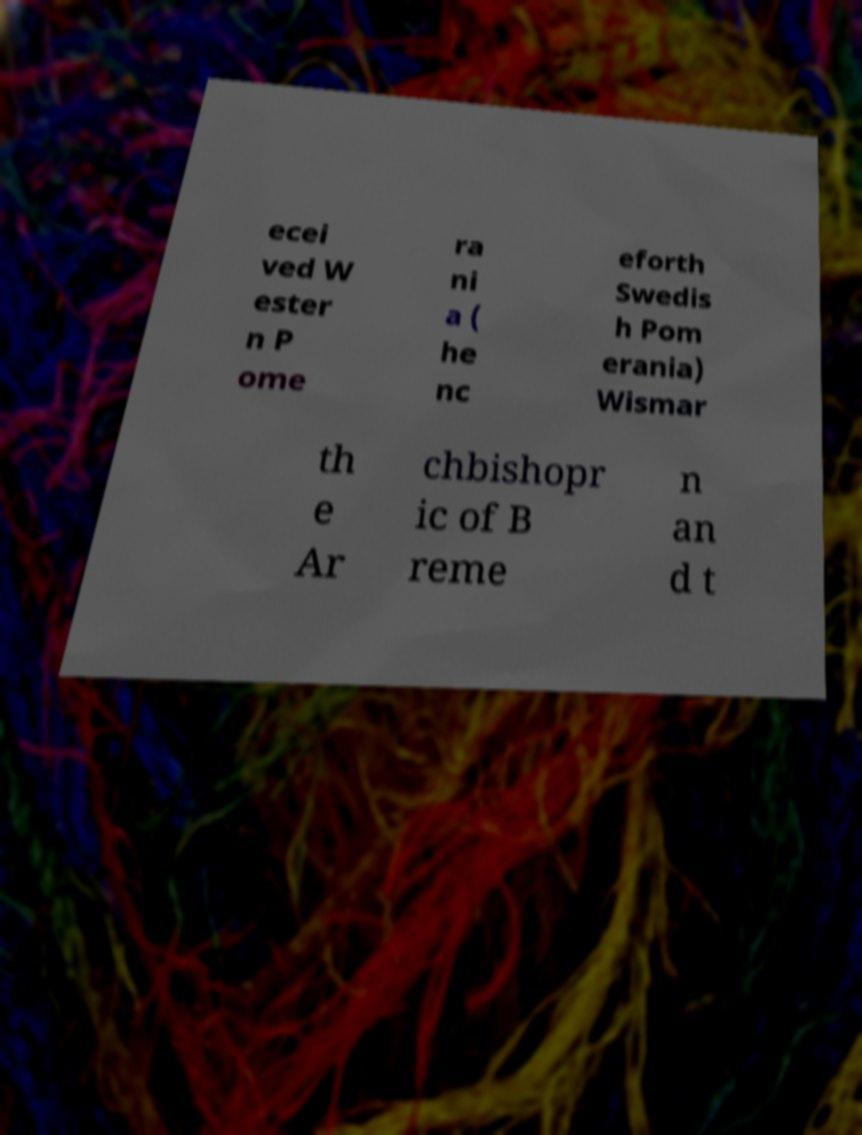Can you read and provide the text displayed in the image?This photo seems to have some interesting text. Can you extract and type it out for me? ecei ved W ester n P ome ra ni a ( he nc eforth Swedis h Pom erania) Wismar th e Ar chbishopr ic of B reme n an d t 